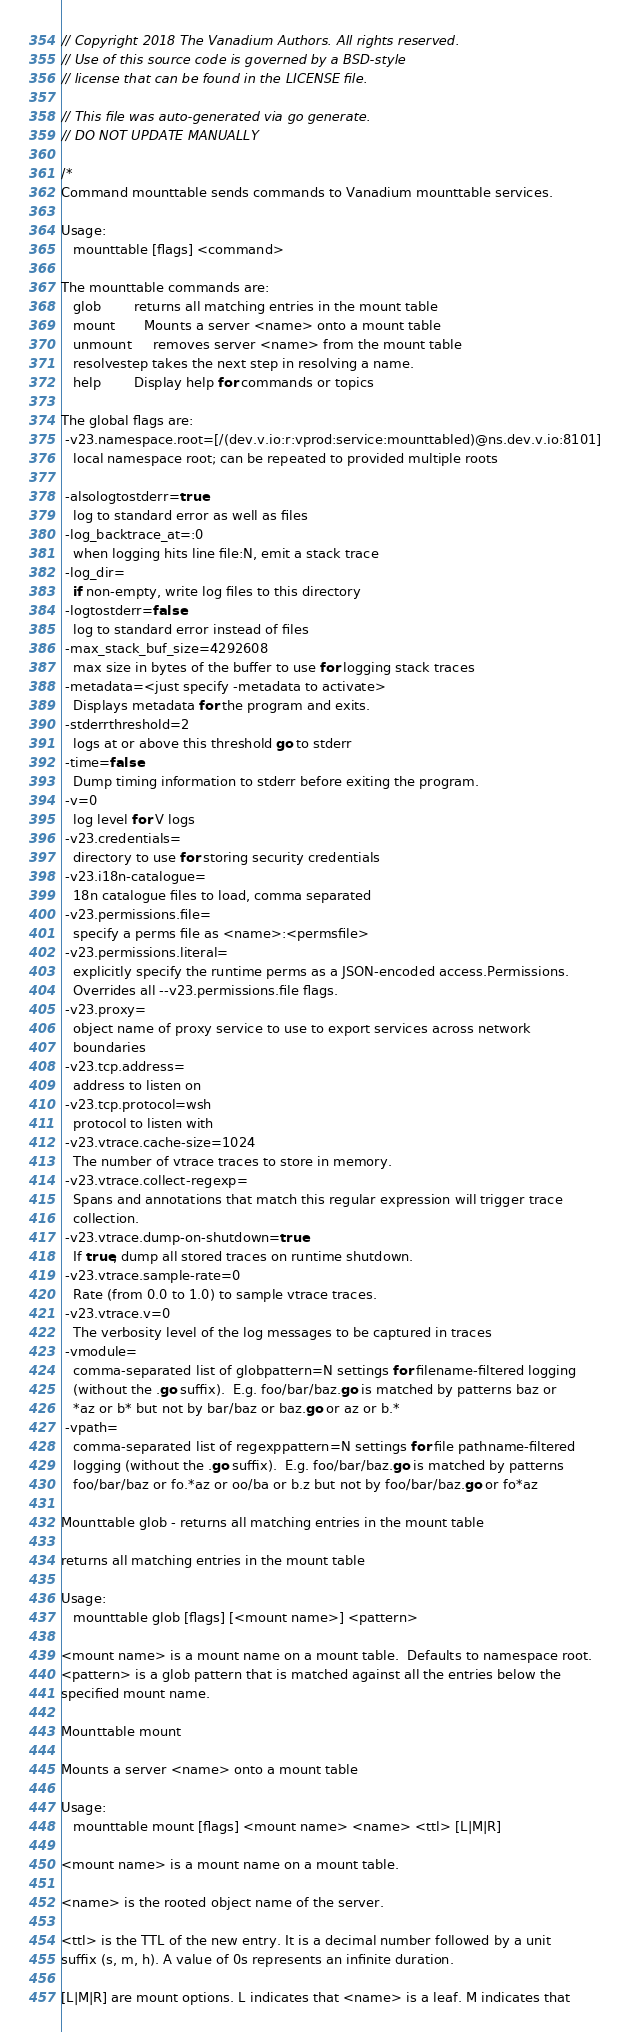Convert code to text. <code><loc_0><loc_0><loc_500><loc_500><_Go_>// Copyright 2018 The Vanadium Authors. All rights reserved.
// Use of this source code is governed by a BSD-style
// license that can be found in the LICENSE file.

// This file was auto-generated via go generate.
// DO NOT UPDATE MANUALLY

/*
Command mounttable sends commands to Vanadium mounttable services.

Usage:
   mounttable [flags] <command>

The mounttable commands are:
   glob        returns all matching entries in the mount table
   mount       Mounts a server <name> onto a mount table
   unmount     removes server <name> from the mount table
   resolvestep takes the next step in resolving a name.
   help        Display help for commands or topics

The global flags are:
 -v23.namespace.root=[/(dev.v.io:r:vprod:service:mounttabled)@ns.dev.v.io:8101]
   local namespace root; can be repeated to provided multiple roots

 -alsologtostderr=true
   log to standard error as well as files
 -log_backtrace_at=:0
   when logging hits line file:N, emit a stack trace
 -log_dir=
   if non-empty, write log files to this directory
 -logtostderr=false
   log to standard error instead of files
 -max_stack_buf_size=4292608
   max size in bytes of the buffer to use for logging stack traces
 -metadata=<just specify -metadata to activate>
   Displays metadata for the program and exits.
 -stderrthreshold=2
   logs at or above this threshold go to stderr
 -time=false
   Dump timing information to stderr before exiting the program.
 -v=0
   log level for V logs
 -v23.credentials=
   directory to use for storing security credentials
 -v23.i18n-catalogue=
   18n catalogue files to load, comma separated
 -v23.permissions.file=
   specify a perms file as <name>:<permsfile>
 -v23.permissions.literal=
   explicitly specify the runtime perms as a JSON-encoded access.Permissions.
   Overrides all --v23.permissions.file flags.
 -v23.proxy=
   object name of proxy service to use to export services across network
   boundaries
 -v23.tcp.address=
   address to listen on
 -v23.tcp.protocol=wsh
   protocol to listen with
 -v23.vtrace.cache-size=1024
   The number of vtrace traces to store in memory.
 -v23.vtrace.collect-regexp=
   Spans and annotations that match this regular expression will trigger trace
   collection.
 -v23.vtrace.dump-on-shutdown=true
   If true, dump all stored traces on runtime shutdown.
 -v23.vtrace.sample-rate=0
   Rate (from 0.0 to 1.0) to sample vtrace traces.
 -v23.vtrace.v=0
   The verbosity level of the log messages to be captured in traces
 -vmodule=
   comma-separated list of globpattern=N settings for filename-filtered logging
   (without the .go suffix).  E.g. foo/bar/baz.go is matched by patterns baz or
   *az or b* but not by bar/baz or baz.go or az or b.*
 -vpath=
   comma-separated list of regexppattern=N settings for file pathname-filtered
   logging (without the .go suffix).  E.g. foo/bar/baz.go is matched by patterns
   foo/bar/baz or fo.*az or oo/ba or b.z but not by foo/bar/baz.go or fo*az

Mounttable glob - returns all matching entries in the mount table

returns all matching entries in the mount table

Usage:
   mounttable glob [flags] [<mount name>] <pattern>

<mount name> is a mount name on a mount table.  Defaults to namespace root.
<pattern> is a glob pattern that is matched against all the entries below the
specified mount name.

Mounttable mount

Mounts a server <name> onto a mount table

Usage:
   mounttable mount [flags] <mount name> <name> <ttl> [L|M|R]

<mount name> is a mount name on a mount table.

<name> is the rooted object name of the server.

<ttl> is the TTL of the new entry. It is a decimal number followed by a unit
suffix (s, m, h). A value of 0s represents an infinite duration.

[L|M|R] are mount options. L indicates that <name> is a leaf. M indicates that</code> 